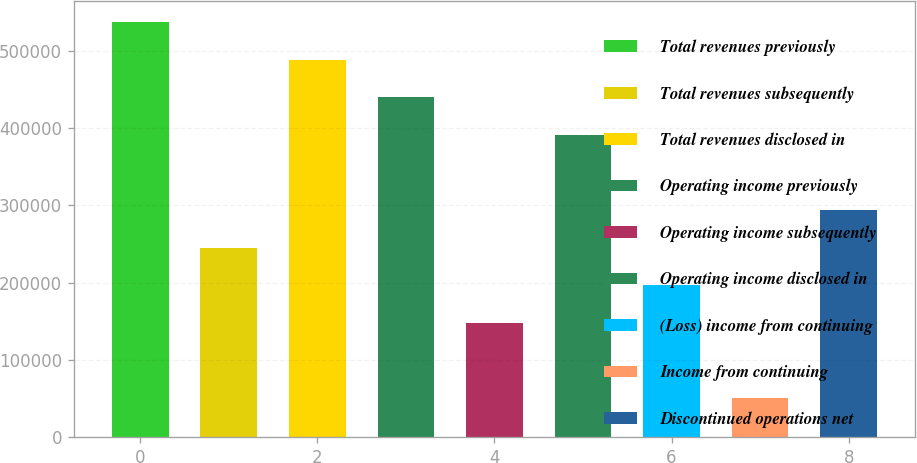Convert chart to OTSL. <chart><loc_0><loc_0><loc_500><loc_500><bar_chart><fcel>Total revenues previously<fcel>Total revenues subsequently<fcel>Total revenues disclosed in<fcel>Operating income previously<fcel>Operating income subsequently<fcel>Operating income disclosed in<fcel>(Loss) income from continuing<fcel>Income from continuing<fcel>Discontinued operations net<nl><fcel>537338<fcel>245449<fcel>488690<fcel>440042<fcel>148153<fcel>391394<fcel>196801<fcel>50856.2<fcel>294097<nl></chart> 